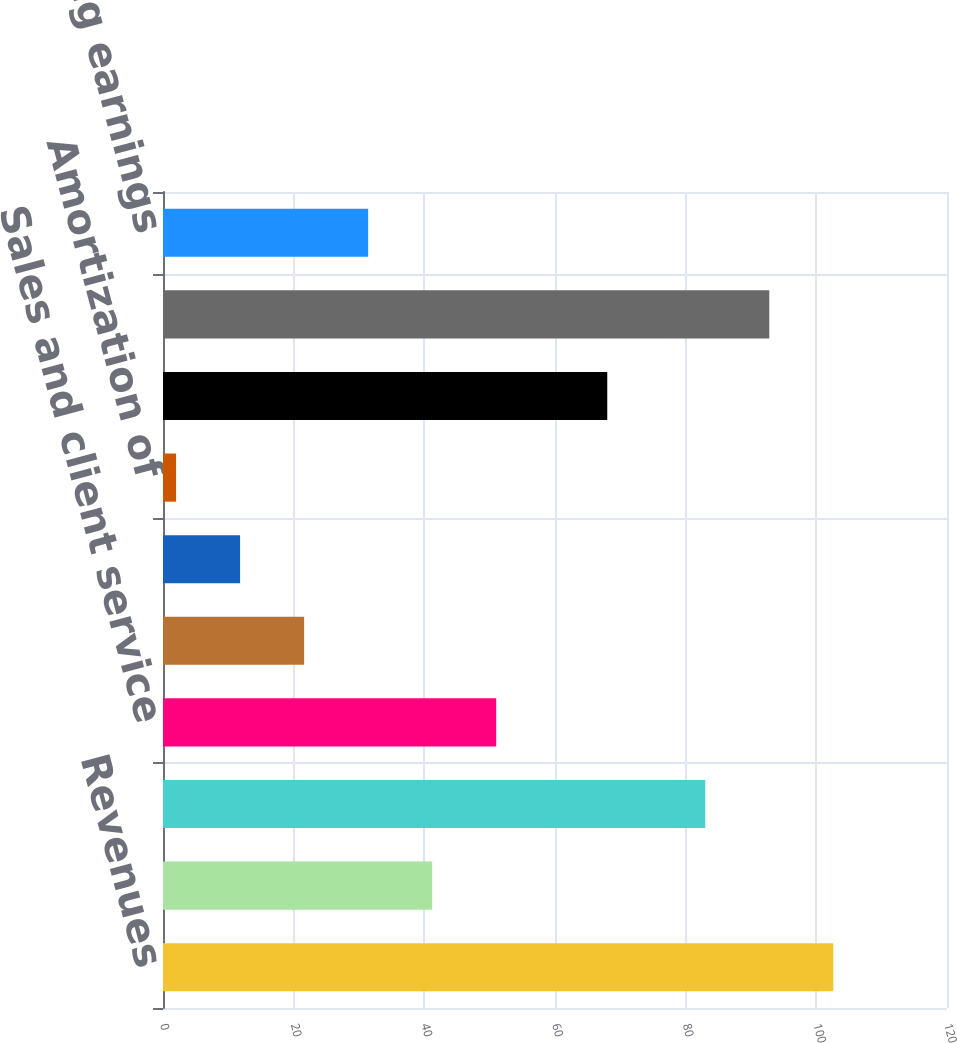Convert chart to OTSL. <chart><loc_0><loc_0><loc_500><loc_500><bar_chart><fcel>Revenues<fcel>Costs of revenue<fcel>Margin<fcel>Sales and client service<fcel>Software development<fcel>General and administrative<fcel>Amortization of<fcel>Total operating expenses<fcel>Total costs and expenses<fcel>Operating earnings<nl><fcel>102.6<fcel>41.2<fcel>83<fcel>51<fcel>21.6<fcel>11.8<fcel>2<fcel>68<fcel>92.8<fcel>31.4<nl></chart> 